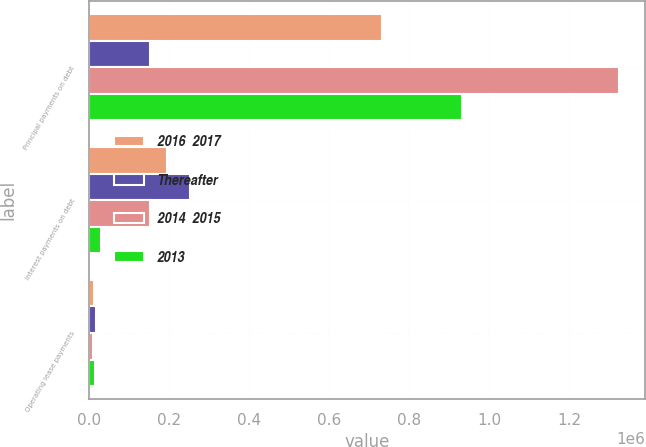<chart> <loc_0><loc_0><loc_500><loc_500><stacked_bar_chart><ecel><fcel>Principal payments on debt<fcel>Interest payments on debt<fcel>Operating lease payments<nl><fcel>2016  2017<fcel>732105<fcel>193255<fcel>12556<nl><fcel>Thereafter<fcel>151263<fcel>252679<fcel>15913<nl><fcel>2014  2015<fcel>1.32414e+06<fcel>151263<fcel>10206<nl><fcel>2013<fcel>932540<fcel>29094<fcel>14269<nl></chart> 